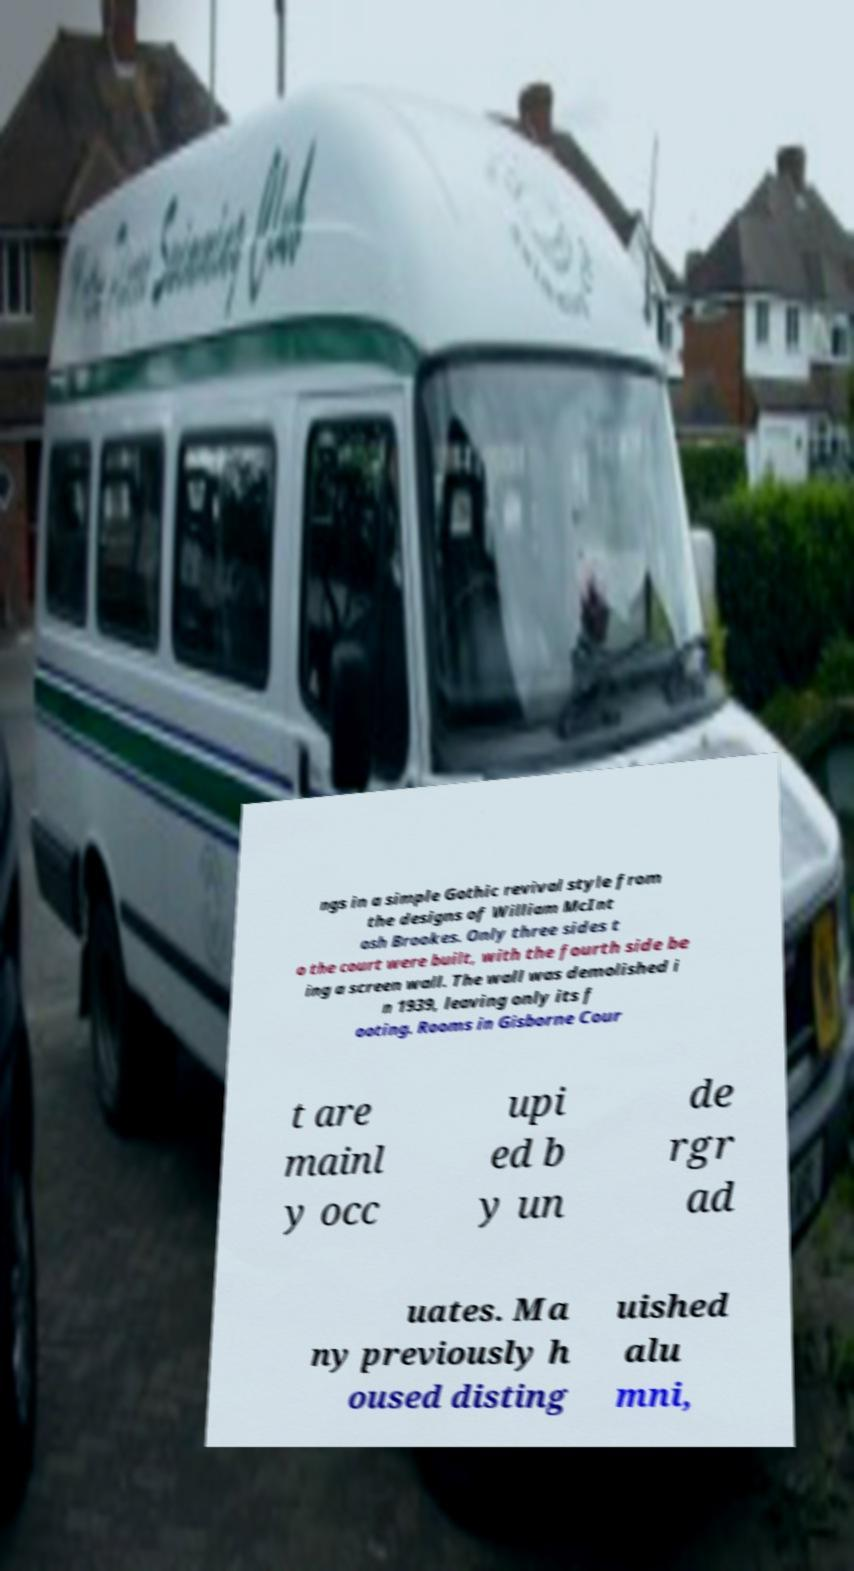Can you read and provide the text displayed in the image?This photo seems to have some interesting text. Can you extract and type it out for me? ngs in a simple Gothic revival style from the designs of William McInt osh Brookes. Only three sides t o the court were built, with the fourth side be ing a screen wall. The wall was demolished i n 1939, leaving only its f ooting. Rooms in Gisborne Cour t are mainl y occ upi ed b y un de rgr ad uates. Ma ny previously h oused disting uished alu mni, 